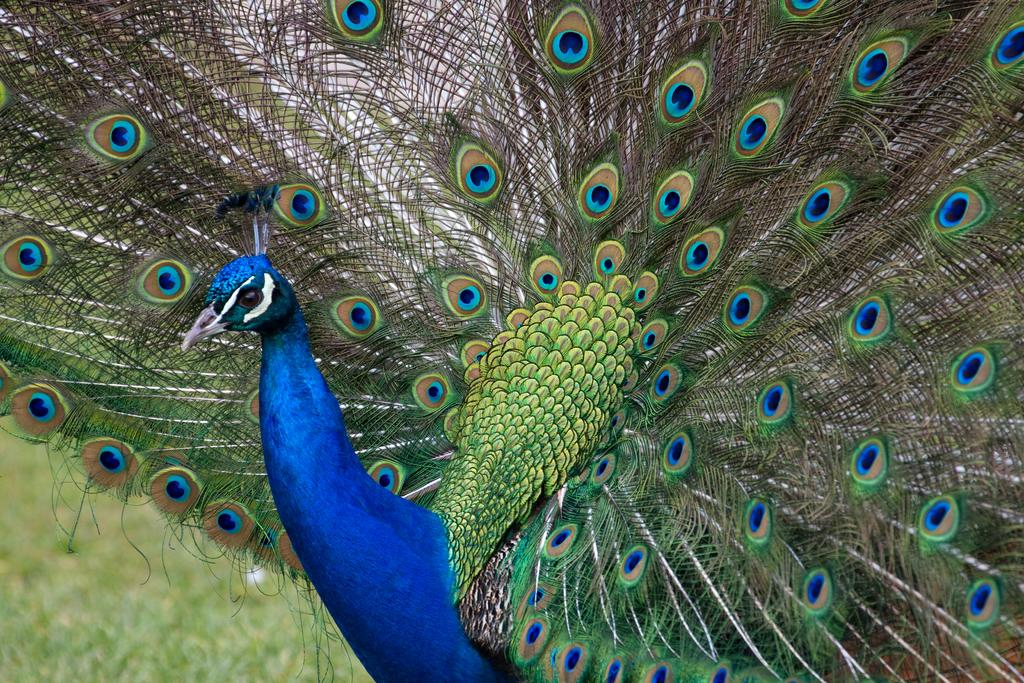What type of animal is in the image? There is a peacock in the image. What can be seen in the background of the image? There is greenery in the image. Can you describe the left side bottom corner of the image? The left side bottom corner of the image has a blurry view. What type of engine can be seen in the image? There is no engine present in the image; it features a peacock and greenery. How many houses are visible in the image? There are no houses visible in the image; it features a peacock and greenery. 